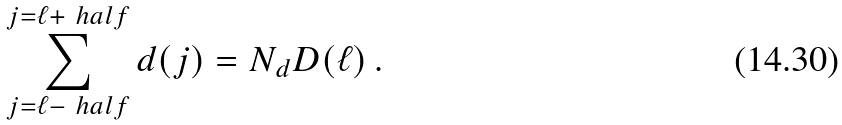Convert formula to latex. <formula><loc_0><loc_0><loc_500><loc_500>\sum _ { j = \ell - \ h a l f } ^ { j = \ell + \ h a l f } d ( j ) = N _ { d } D ( \ell ) \, .</formula> 